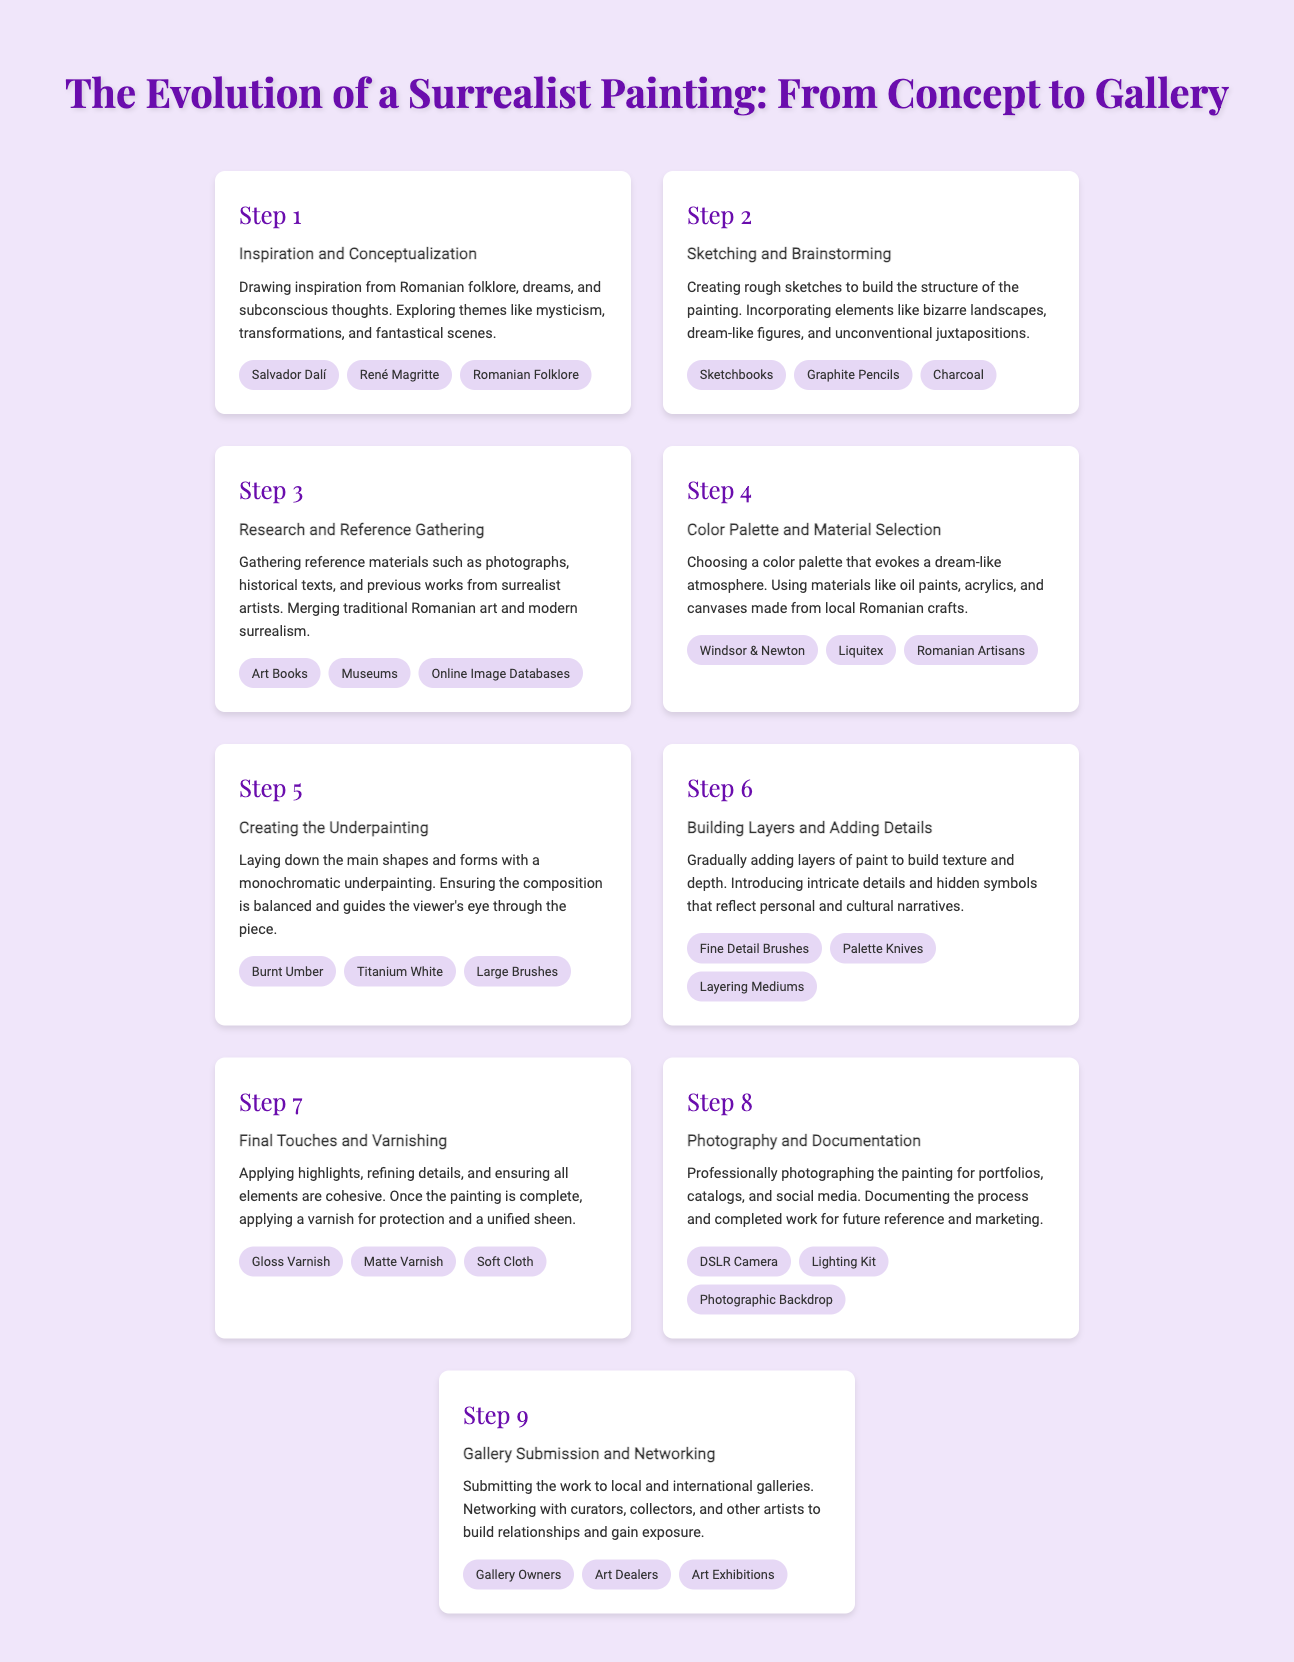What is the first step in creating a surrealist painting? The first step mentioned in the document is "Inspiration and Conceptualization," where artists draw inspiration from folklore and dreams.
Answer: Inspiration and Conceptualization Which materials are chosen in Step 4? In Step 4, the document lists oil paints, acrylics, and canvases made from local Romanian crafts as materials selected.
Answer: Oil paints, acrylics, and canvases What is used for underpainting? The step on underpainting mentions "Burnt Umber" and "Titanium White" as materials used.
Answer: Burnt Umber and Titanium White How many steps are outlined in the process infographic? The document presents a total of 9 steps for creating a surrealist painting.
Answer: 9 What is the last step before submitting to galleries? The last step mentioned is "Photography and Documentation," which focuses on professionally photographing the painting.
Answer: Photography and Documentation Which artist is referenced in the conceptualization phase? The document references Salvador Dalí as an influential figure in the "Inspiration and Conceptualization" phase.
Answer: Salvador Dalí What type of camera is mentioned for documentation? A "DSLR Camera" is specified for professional photography of the painting.
Answer: DSLR Camera What key activity takes place during Step 6? In Step 6, the activity of "Building Layers and Adding Details" is emphasized, where texture and depth are created.
Answer: Building Layers and Adding Details What is the purpose of applying varnish in the final step? The varnish is applied to protect the painting and provide a unified sheen, as outlined in the "Final Touches and Varnishing" step.
Answer: Protection and unified sheen 